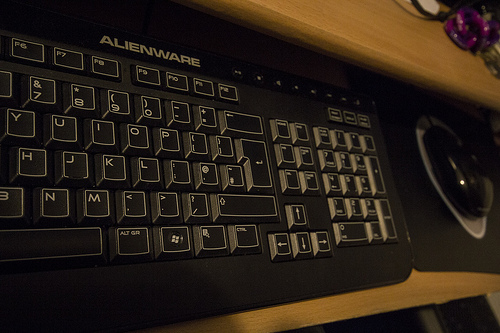Is the lighting condition suitable for computer work? The image displays a dimly lit environment which may not be ideal for prolonged computer work, potentially causing eye strain. Proper task lighting is recommended for a comfortable workstation. How can the lighting be improved? Improving lighting can be achieved by adding a desk lamp with an adjustable arm or by ensuring the room's overhead lighting provides even, diffuse light to minimize glare on the screen. 